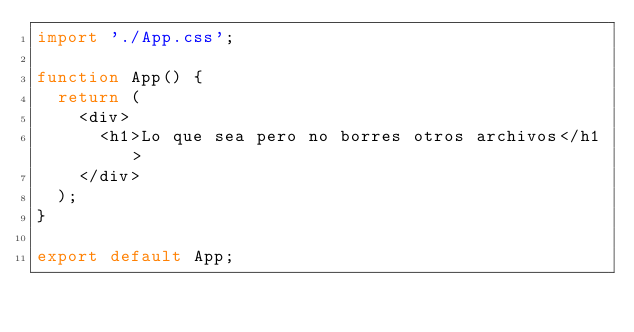Convert code to text. <code><loc_0><loc_0><loc_500><loc_500><_JavaScript_>import './App.css';

function App() {
  return (
    <div>
      <h1>Lo que sea pero no borres otros archivos</h1>
    </div>
  );
}

export default App;
</code> 